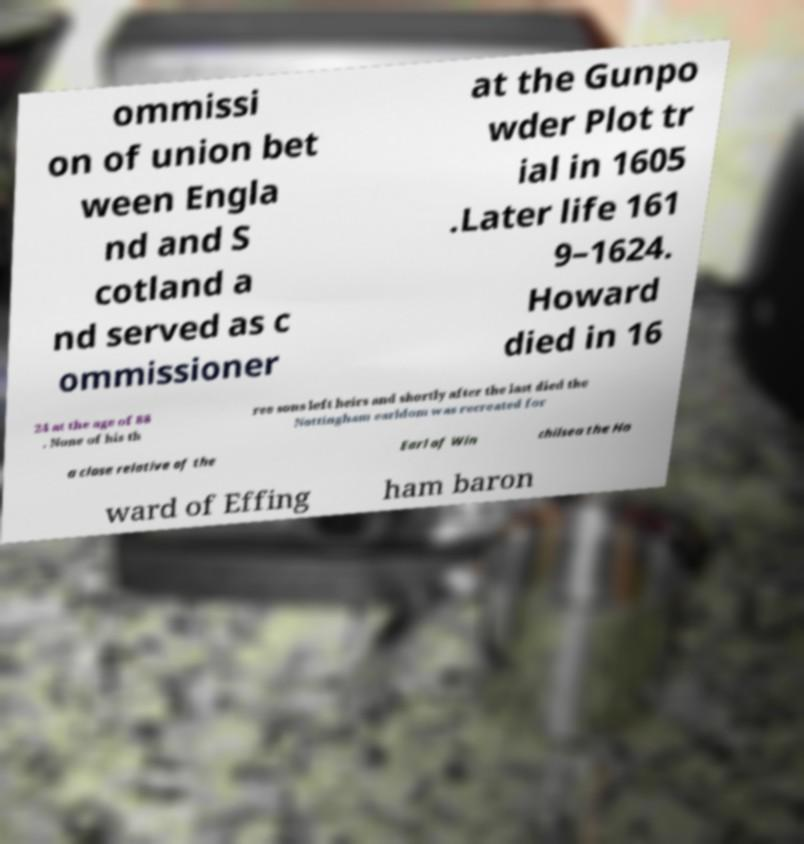Please read and relay the text visible in this image. What does it say? ommissi on of union bet ween Engla nd and S cotland a nd served as c ommissioner at the Gunpo wder Plot tr ial in 1605 .Later life 161 9–1624. Howard died in 16 24 at the age of 88 . None of his th ree sons left heirs and shortly after the last died the Nottingham earldom was recreated for a close relative of the Earl of Win chilsea the Ho ward of Effing ham baron 